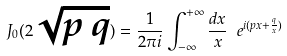Convert formula to latex. <formula><loc_0><loc_0><loc_500><loc_500>J _ { 0 } ( 2 \sqrt { p \, q } ) = \frac { 1 } { 2 \pi i } \int _ { - \infty } ^ { + \infty } \frac { d x } { x } \ e ^ { i ( p x + \frac { q } { x } ) }</formula> 